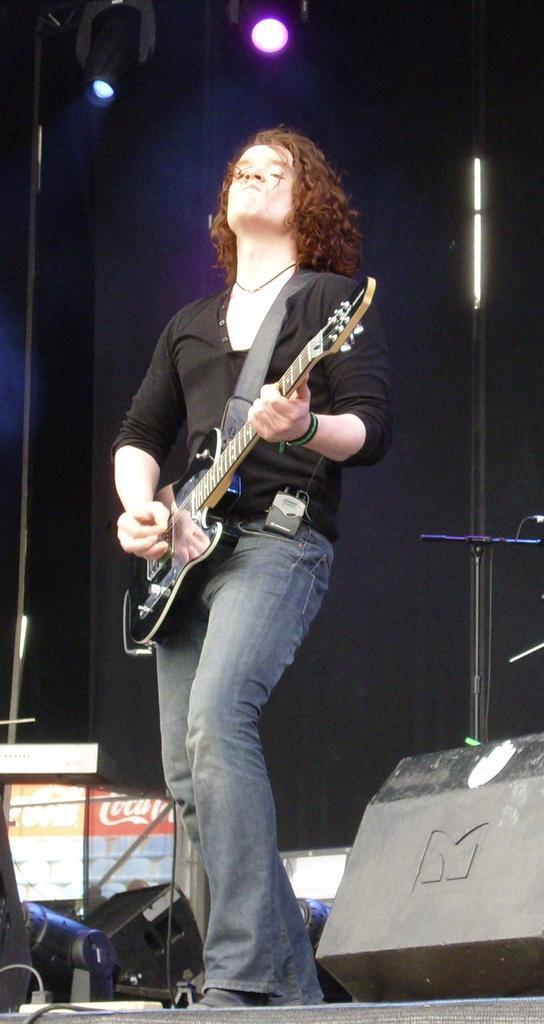What is the person in the image doing? The person is holding a guitar and moving the strings of the guitar. What might be the purpose of the person's actions? The person's actions suggest they are playing the guitar, possibly as part of a stage performance. What can be seen in the background of the image? There is a black-colored wall and a flashlight in the background. What type of setting is suggested by the presence of a stage performance? The setting suggests a performance or concert venue. Can you see a woman holding a twig in the image? There is no woman holding a twig in the image; it features a person playing a guitar on a stage. 